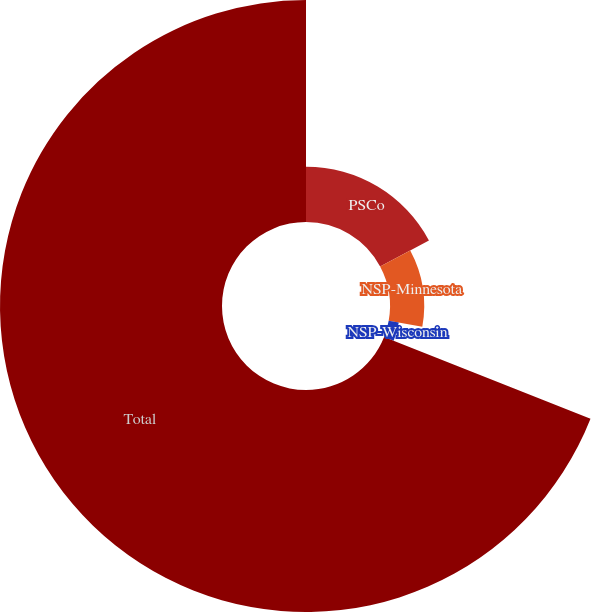Convert chart to OTSL. <chart><loc_0><loc_0><loc_500><loc_500><pie_chart><fcel>PSCo<fcel>NSP-Minnesota<fcel>NSP-Wisconsin<fcel>Total<nl><fcel>17.2%<fcel>10.62%<fcel>3.18%<fcel>69.0%<nl></chart> 